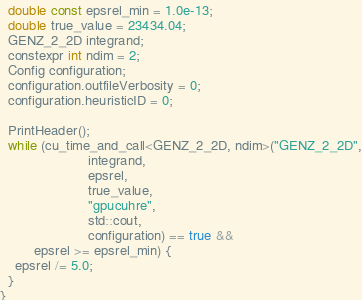<code> <loc_0><loc_0><loc_500><loc_500><_Cuda_>  double const epsrel_min = 1.0e-13;
  double true_value = 23434.04;
  GENZ_2_2D integrand;
  constexpr int ndim = 2;
  Config configuration;
  configuration.outfileVerbosity = 0;
  configuration.heuristicID = 0;
  
  PrintHeader();
  while (cu_time_and_call<GENZ_2_2D, ndim>("GENZ_2_2D",
                       integrand,
                       epsrel,
                       true_value,
                       "gpucuhre",
                       std::cout,
                       configuration) == true &&
         epsrel >= epsrel_min) {
    epsrel /= 5.0;
  }
}
</code> 